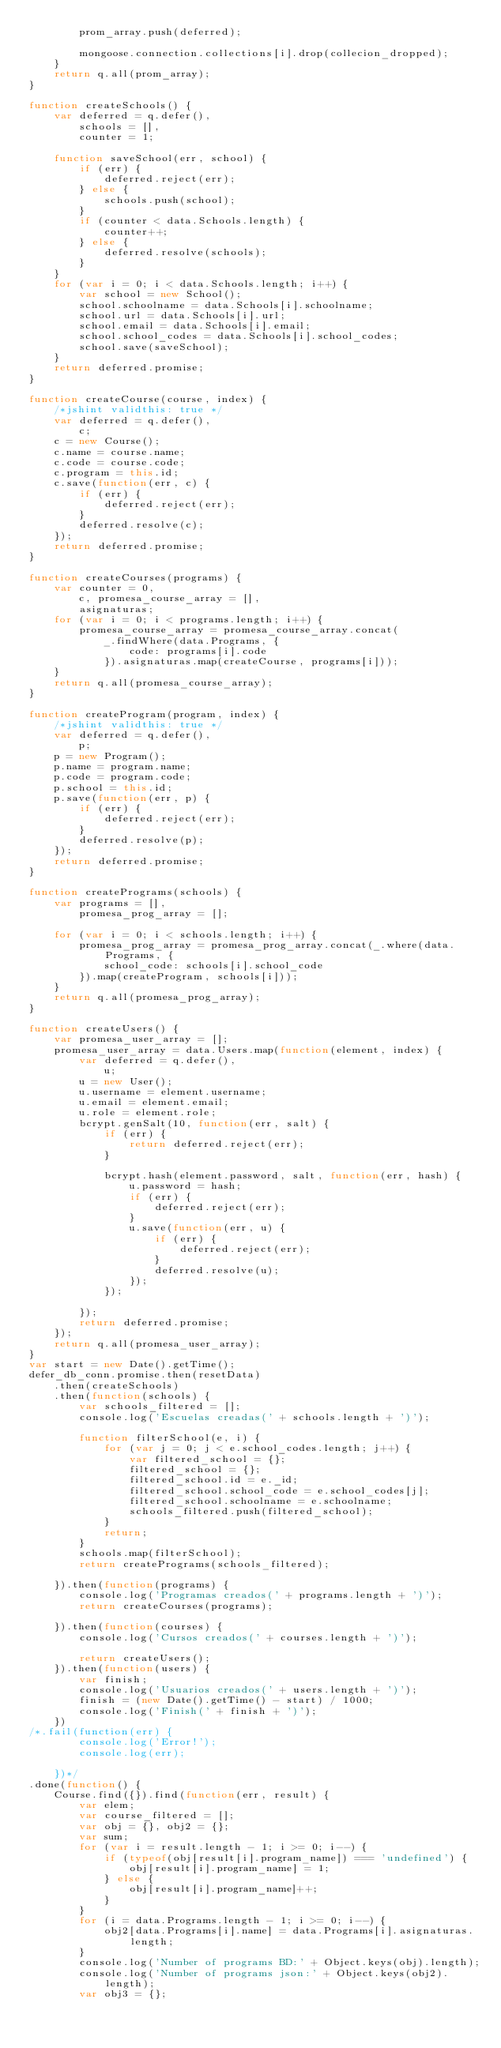<code> <loc_0><loc_0><loc_500><loc_500><_JavaScript_>        prom_array.push(deferred);

        mongoose.connection.collections[i].drop(collecion_dropped);
    }
    return q.all(prom_array);
}

function createSchools() {
    var deferred = q.defer(),
        schools = [],
        counter = 1;

    function saveSchool(err, school) {
        if (err) {
            deferred.reject(err);
        } else {
            schools.push(school);
        }
        if (counter < data.Schools.length) {
            counter++;
        } else {
            deferred.resolve(schools);
        }
    }
    for (var i = 0; i < data.Schools.length; i++) {
        var school = new School();
        school.schoolname = data.Schools[i].schoolname;
        school.url = data.Schools[i].url;
        school.email = data.Schools[i].email;
        school.school_codes = data.Schools[i].school_codes;
        school.save(saveSchool);
    }
    return deferred.promise;
}

function createCourse(course, index) {
    /*jshint validthis: true */
    var deferred = q.defer(),
        c;
    c = new Course();
    c.name = course.name;
    c.code = course.code;
    c.program = this.id;
    c.save(function(err, c) {
        if (err) {
            deferred.reject(err);
        }
        deferred.resolve(c);
    });
    return deferred.promise;
}

function createCourses(programs) {
    var counter = 0,
        c, promesa_course_array = [],
        asignaturas;
    for (var i = 0; i < programs.length; i++) {
        promesa_course_array = promesa_course_array.concat(
            _.findWhere(data.Programs, {
                code: programs[i].code
            }).asignaturas.map(createCourse, programs[i]));
    }
    return q.all(promesa_course_array);
}

function createProgram(program, index) {
    /*jshint validthis: true */
    var deferred = q.defer(),
        p;
    p = new Program();
    p.name = program.name;
    p.code = program.code;
    p.school = this.id;
    p.save(function(err, p) {
        if (err) {
            deferred.reject(err);
        }
        deferred.resolve(p);
    });
    return deferred.promise;
}

function createPrograms(schools) {
    var programs = [],
        promesa_prog_array = [];

    for (var i = 0; i < schools.length; i++) {
        promesa_prog_array = promesa_prog_array.concat(_.where(data.Programs, {
            school_code: schools[i].school_code
        }).map(createProgram, schools[i]));
    }
    return q.all(promesa_prog_array);
}

function createUsers() {
    var promesa_user_array = [];
    promesa_user_array = data.Users.map(function(element, index) {
        var deferred = q.defer(),
            u;
        u = new User();
        u.username = element.username;
        u.email = element.email;
        u.role = element.role;
        bcrypt.genSalt(10, function(err, salt) {
            if (err) {
                return deferred.reject(err);
            }

            bcrypt.hash(element.password, salt, function(err, hash) {
                u.password = hash;
                if (err) {
                    deferred.reject(err);
                }
                u.save(function(err, u) {
                    if (err) {
                        deferred.reject(err);
                    }
                    deferred.resolve(u);
                });
            });

        });
        return deferred.promise;
    });
    return q.all(promesa_user_array);
}
var start = new Date().getTime();
defer_db_conn.promise.then(resetData)
    .then(createSchools)
    .then(function(schools) {
        var schools_filtered = [];
        console.log('Escuelas creadas(' + schools.length + ')');

        function filterSchool(e, i) {
            for (var j = 0; j < e.school_codes.length; j++) {
                var filtered_school = {};
                filtered_school = {};
                filtered_school.id = e._id;
                filtered_school.school_code = e.school_codes[j];
                filtered_school.schoolname = e.schoolname;
                schools_filtered.push(filtered_school);
            }
            return;
        }
        schools.map(filterSchool);
        return createPrograms(schools_filtered);

    }).then(function(programs) {
        console.log('Programas creados(' + programs.length + ')');
        return createCourses(programs);

    }).then(function(courses) {
        console.log('Cursos creados(' + courses.length + ')');

        return createUsers();
    }).then(function(users) {
        var finish;
        console.log('Usuarios creados(' + users.length + ')');
        finish = (new Date().getTime() - start) / 1000;
        console.log('Finish(' + finish + ')');
    })
/*.fail(function(err) {
        console.log('Error!');
        console.log(err);

    })*/
.done(function() {
    Course.find({}).find(function(err, result) {
        var elem;
        var course_filtered = [];
        var obj = {}, obj2 = {};
        var sum;
        for (var i = result.length - 1; i >= 0; i--) {
            if (typeof(obj[result[i].program_name]) === 'undefined') {
                obj[result[i].program_name] = 1;
            } else {
                obj[result[i].program_name]++;
            }
        }
        for (i = data.Programs.length - 1; i >= 0; i--) {
            obj2[data.Programs[i].name] = data.Programs[i].asignaturas.length;
        }
        console.log('Number of programs BD:' + Object.keys(obj).length);
        console.log('Number of programs json:' + Object.keys(obj2).length);
        var obj3 = {};</code> 